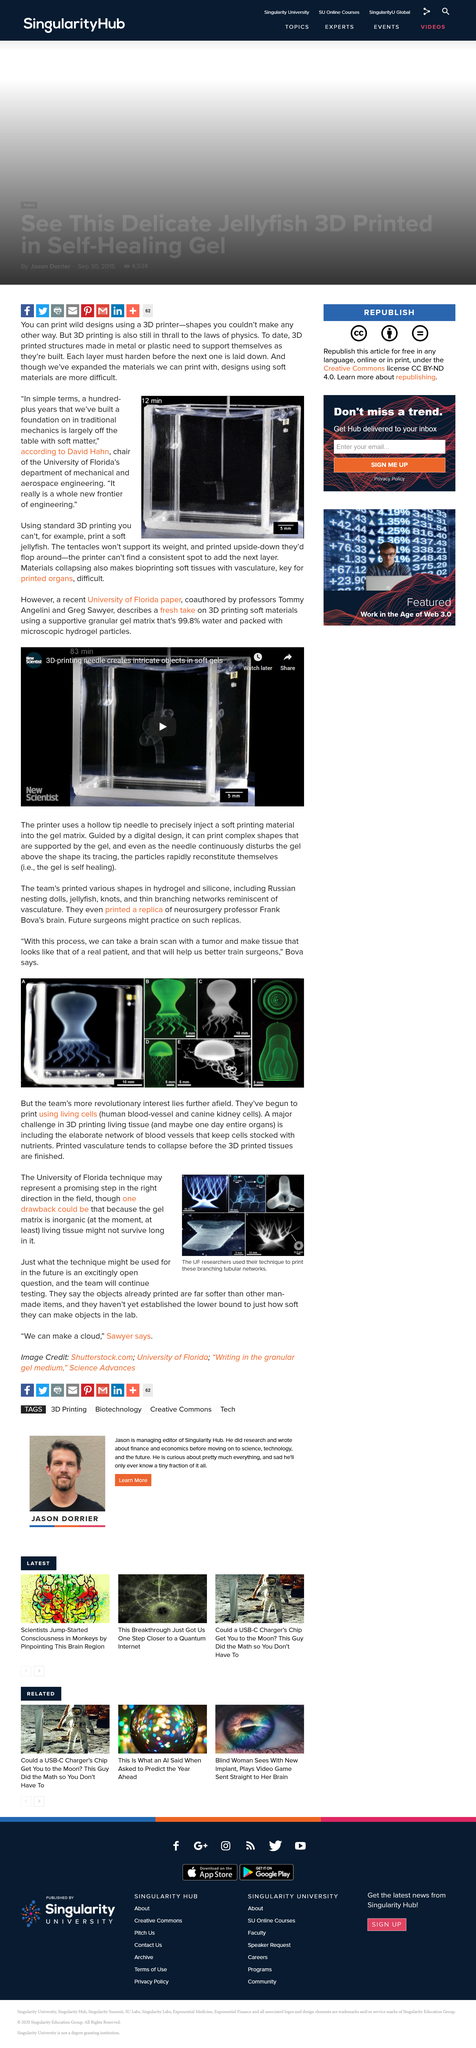Highlight a few significant elements in this photo. The printer did not create a replica of an animal brain, but rather a replica of a human brain. The scale on image A is 10 millimeters. Bova's team has commenced the printing of living cells, which marks the beginning of a groundbreaking new technology. David Hahn is the chair of the University of Florida's department of mechanical and aerospace engineering. The objects printed are far softer than other man-made items. 